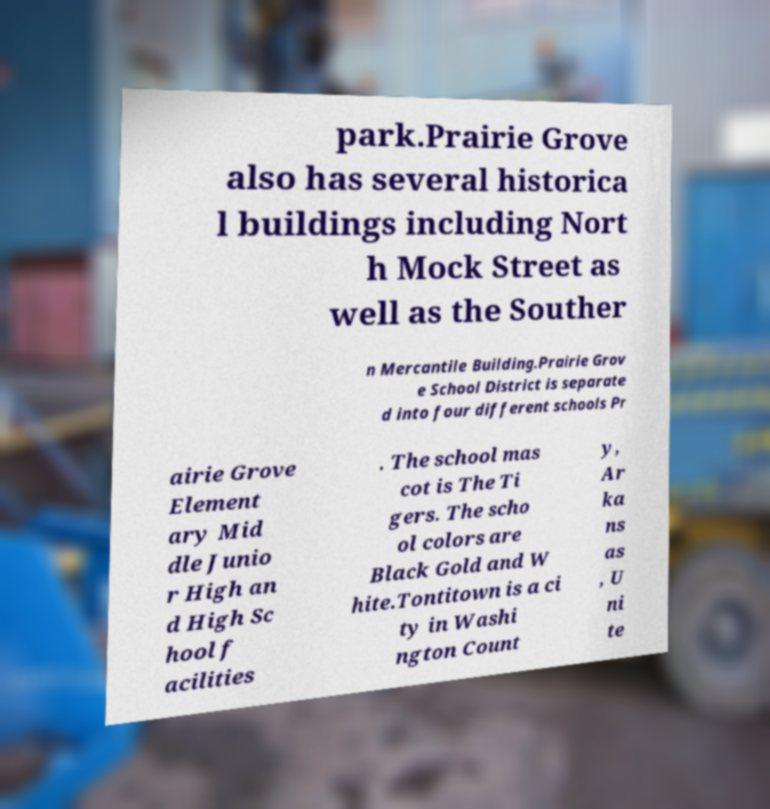Can you accurately transcribe the text from the provided image for me? park.Prairie Grove also has several historica l buildings including Nort h Mock Street as well as the Souther n Mercantile Building.Prairie Grov e School District is separate d into four different schools Pr airie Grove Element ary Mid dle Junio r High an d High Sc hool f acilities . The school mas cot is The Ti gers. The scho ol colors are Black Gold and W hite.Tontitown is a ci ty in Washi ngton Count y, Ar ka ns as , U ni te 